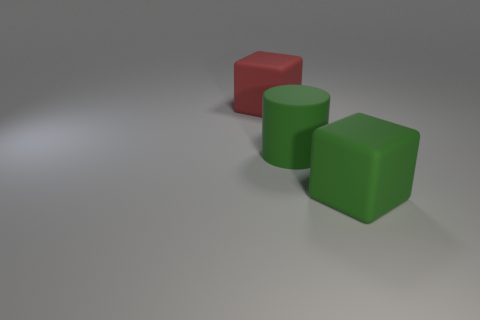Add 1 large green rubber cylinders. How many objects exist? 4 Subtract all cubes. How many objects are left? 1 Add 2 big red objects. How many big red objects are left? 3 Add 1 big cylinders. How many big cylinders exist? 2 Subtract 0 blue balls. How many objects are left? 3 Subtract all red matte things. Subtract all blue cylinders. How many objects are left? 2 